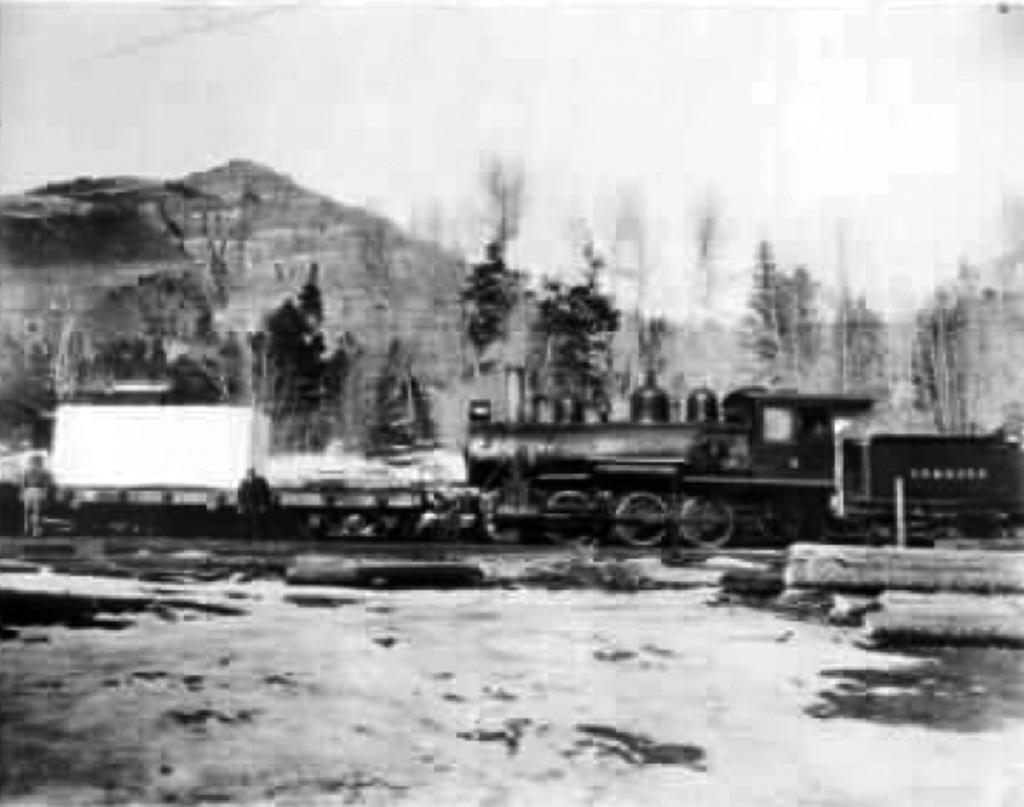What is the main subject of the picture? The main subject of the picture is a train. What other elements can be seen in the picture? There are trees, a mountain, and the sky visible in the picture. What is the color scheme of the picture? The picture is black and white in color. What type of destruction can be seen in the picture? There is no destruction present in the picture; it features a train, trees, a mountain, and the sky in a black and white color scheme. What is the train using to comb its hair in the picture? There is no train with hair in the picture, and therefore no comb is present. 